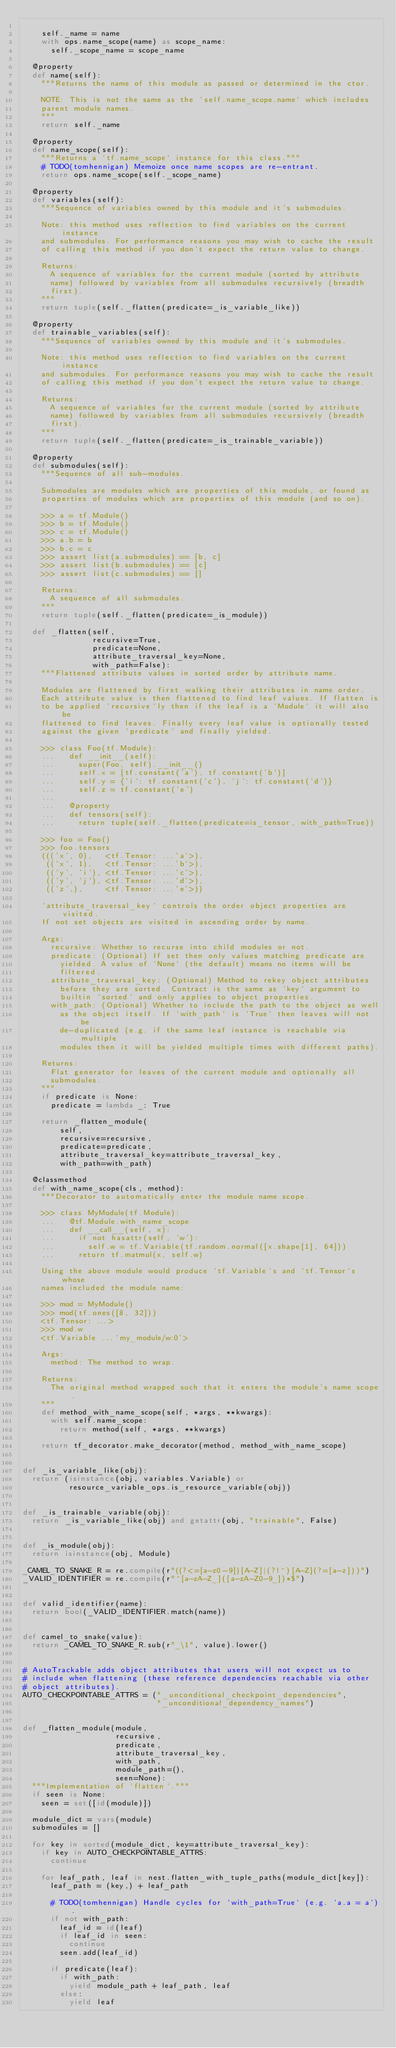Convert code to text. <code><loc_0><loc_0><loc_500><loc_500><_Python_>
    self._name = name
    with ops.name_scope(name) as scope_name:
      self._scope_name = scope_name

  @property
  def name(self):
    """Returns the name of this module as passed or determined in the ctor.

    NOTE: This is not the same as the `self.name_scope.name` which includes
    parent module names.
    """
    return self._name

  @property
  def name_scope(self):
    """Returns a `tf.name_scope` instance for this class."""
    # TODO(tomhennigan) Memoize once name scopes are re-entrant.
    return ops.name_scope(self._scope_name)

  @property
  def variables(self):
    """Sequence of variables owned by this module and it's submodules.

    Note: this method uses reflection to find variables on the current instance
    and submodules. For performance reasons you may wish to cache the result
    of calling this method if you don't expect the return value to change.

    Returns:
      A sequence of variables for the current module (sorted by attribute
      name) followed by variables from all submodules recursively (breadth
      first).
    """
    return tuple(self._flatten(predicate=_is_variable_like))

  @property
  def trainable_variables(self):
    """Sequence of variables owned by this module and it's submodules.

    Note: this method uses reflection to find variables on the current instance
    and submodules. For performance reasons you may wish to cache the result
    of calling this method if you don't expect the return value to change.

    Returns:
      A sequence of variables for the current module (sorted by attribute
      name) followed by variables from all submodules recursively (breadth
      first).
    """
    return tuple(self._flatten(predicate=_is_trainable_variable))

  @property
  def submodules(self):
    """Sequence of all sub-modules.

    Submodules are modules which are properties of this module, or found as
    properties of modules which are properties of this module (and so on).

    >>> a = tf.Module()
    >>> b = tf.Module()
    >>> c = tf.Module()
    >>> a.b = b
    >>> b.c = c
    >>> assert list(a.submodules) == [b, c]
    >>> assert list(b.submodules) == [c]
    >>> assert list(c.submodules) == []

    Returns:
      A sequence of all submodules.
    """
    return tuple(self._flatten(predicate=_is_module))

  def _flatten(self,
               recursive=True,
               predicate=None,
               attribute_traversal_key=None,
               with_path=False):
    """Flattened attribute values in sorted order by attribute name.

    Modules are flattened by first walking their attributes in name order.
    Each attribute value is then flattened to find leaf values. If flatten is
    to be applied `recursive`ly then if the leaf is a `Module` it will also be
    flattened to find leaves. Finally every leaf value is optionally tested
    against the given `predicate` and finally yielded.

    >>> class Foo(tf.Module):
    ...   def __init__(self):
    ...     super(Foo, self).__init__()
    ...     self.x = [tf.constant('a'), tf.constant('b')]
    ...     self.y = {'i': tf.constant('c'), 'j': tf.constant('d')}
    ...     self.z = tf.constant('e')
    ...
    ...   @property
    ...   def tensors(self):
    ...     return tuple(self._flatten(predicate=is_tensor, with_path=True))

    >>> foo = Foo()
    >>> foo.tensors
    ((('x', 0),   <tf.Tensor: ...'a'>),
     (('x', 1),   <tf.Tensor: ...'b'>),
     (('y', 'i'), <tf.Tensor: ...'c'>),
     (('y', 'j'), <tf.Tensor: ...'d'>),
     (('z',),     <tf.Tensor: ...'e'>))

    `attribute_traversal_key` controls the order object properties are visited.
    If not set objects are visited in ascending order by name.

    Args:
      recursive: Whether to recurse into child modules or not.
      predicate: (Optional) If set then only values matching predicate are
        yielded. A value of `None` (the default) means no items will be
        filtered.
      attribute_traversal_key: (Optional) Method to rekey object attributes
        before they are sorted. Contract is the same as `key` argument to
        builtin `sorted` and only applies to object properties.
      with_path: (Optional) Whether to include the path to the object as well
        as the object itself. If `with_path` is `True` then leaves will not be
        de-duplicated (e.g. if the same leaf instance is reachable via multiple
        modules then it will be yielded multiple times with different paths).

    Returns:
      Flat generator for leaves of the current module and optionally all
      submodules.
    """
    if predicate is None:
      predicate = lambda _: True

    return _flatten_module(
        self,
        recursive=recursive,
        predicate=predicate,
        attribute_traversal_key=attribute_traversal_key,
        with_path=with_path)

  @classmethod
  def with_name_scope(cls, method):
    """Decorator to automatically enter the module name scope.

    >>> class MyModule(tf.Module):
    ...   @tf.Module.with_name_scope
    ...   def __call__(self, x):
    ...     if not hasattr(self, 'w'):
    ...       self.w = tf.Variable(tf.random.normal([x.shape[1], 64]))
    ...     return tf.matmul(x, self.w)

    Using the above module would produce `tf.Variable`s and `tf.Tensor`s whose
    names included the module name:

    >>> mod = MyModule()
    >>> mod(tf.ones([8, 32]))
    <tf.Tensor: ...>
    >>> mod.w
    <tf.Variable ...'my_module/w:0'>

    Args:
      method: The method to wrap.

    Returns:
      The original method wrapped such that it enters the module's name scope.
    """
    def method_with_name_scope(self, *args, **kwargs):
      with self.name_scope:
        return method(self, *args, **kwargs)

    return tf_decorator.make_decorator(method, method_with_name_scope)


def _is_variable_like(obj):
  return (isinstance(obj, variables.Variable) or
          resource_variable_ops.is_resource_variable(obj))


def _is_trainable_variable(obj):
  return _is_variable_like(obj) and getattr(obj, "trainable", False)


def _is_module(obj):
  return isinstance(obj, Module)

_CAMEL_TO_SNAKE_R = re.compile(r"((?<=[a-z0-9])[A-Z]|(?!^)[A-Z](?=[a-z]))")
_VALID_IDENTIFIER = re.compile(r"^[a-zA-Z_]([a-zA-Z0-9_])*$")


def valid_identifier(name):
  return bool(_VALID_IDENTIFIER.match(name))


def camel_to_snake(value):
  return _CAMEL_TO_SNAKE_R.sub(r"_\1", value).lower()


# AutoTrackable adds object attributes that users will not expect us to
# include when flattening (these reference dependencies reachable via other
# object attributes).
AUTO_CHECKPOINTABLE_ATTRS = ("_unconditional_checkpoint_dependencies",
                             "_unconditional_dependency_names")


def _flatten_module(module,
                    recursive,
                    predicate,
                    attribute_traversal_key,
                    with_path,
                    module_path=(),
                    seen=None):
  """Implementation of `flatten`."""
  if seen is None:
    seen = set([id(module)])

  module_dict = vars(module)
  submodules = []

  for key in sorted(module_dict, key=attribute_traversal_key):
    if key in AUTO_CHECKPOINTABLE_ATTRS:
      continue

    for leaf_path, leaf in nest.flatten_with_tuple_paths(module_dict[key]):
      leaf_path = (key,) + leaf_path

      # TODO(tomhennigan) Handle cycles for `with_path=True` (e.g. `a.a = a`).
      if not with_path:
        leaf_id = id(leaf)
        if leaf_id in seen:
          continue
        seen.add(leaf_id)

      if predicate(leaf):
        if with_path:
          yield module_path + leaf_path, leaf
        else:
          yield leaf
</code> 